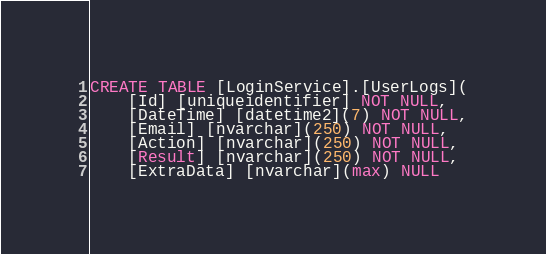Convert code to text. <code><loc_0><loc_0><loc_500><loc_500><_SQL_>CREATE TABLE [LoginService].[UserLogs](
	[Id] [uniqueidentifier] NOT NULL,
	[DateTime] [datetime2](7) NOT NULL,
	[Email] [nvarchar](250) NOT NULL,
	[Action] [nvarchar](250) NOT NULL,
	[Result] [nvarchar](250) NOT NULL,
	[ExtraData] [nvarchar](max) NULL</code> 